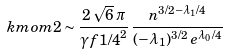Convert formula to latex. <formula><loc_0><loc_0><loc_500><loc_500>\ k m o m { 2 } \sim \frac { 2 \, \sqrt { 6 } \, \pi } { \gamma f { 1 / 4 } ^ { 2 } } \, \frac { n ^ { 3 / 2 - \lambda _ { 1 } / 4 } } { ( - \lambda _ { 1 } ) ^ { 3 / 2 } \, e ^ { \lambda _ { 0 } / 4 } }</formula> 